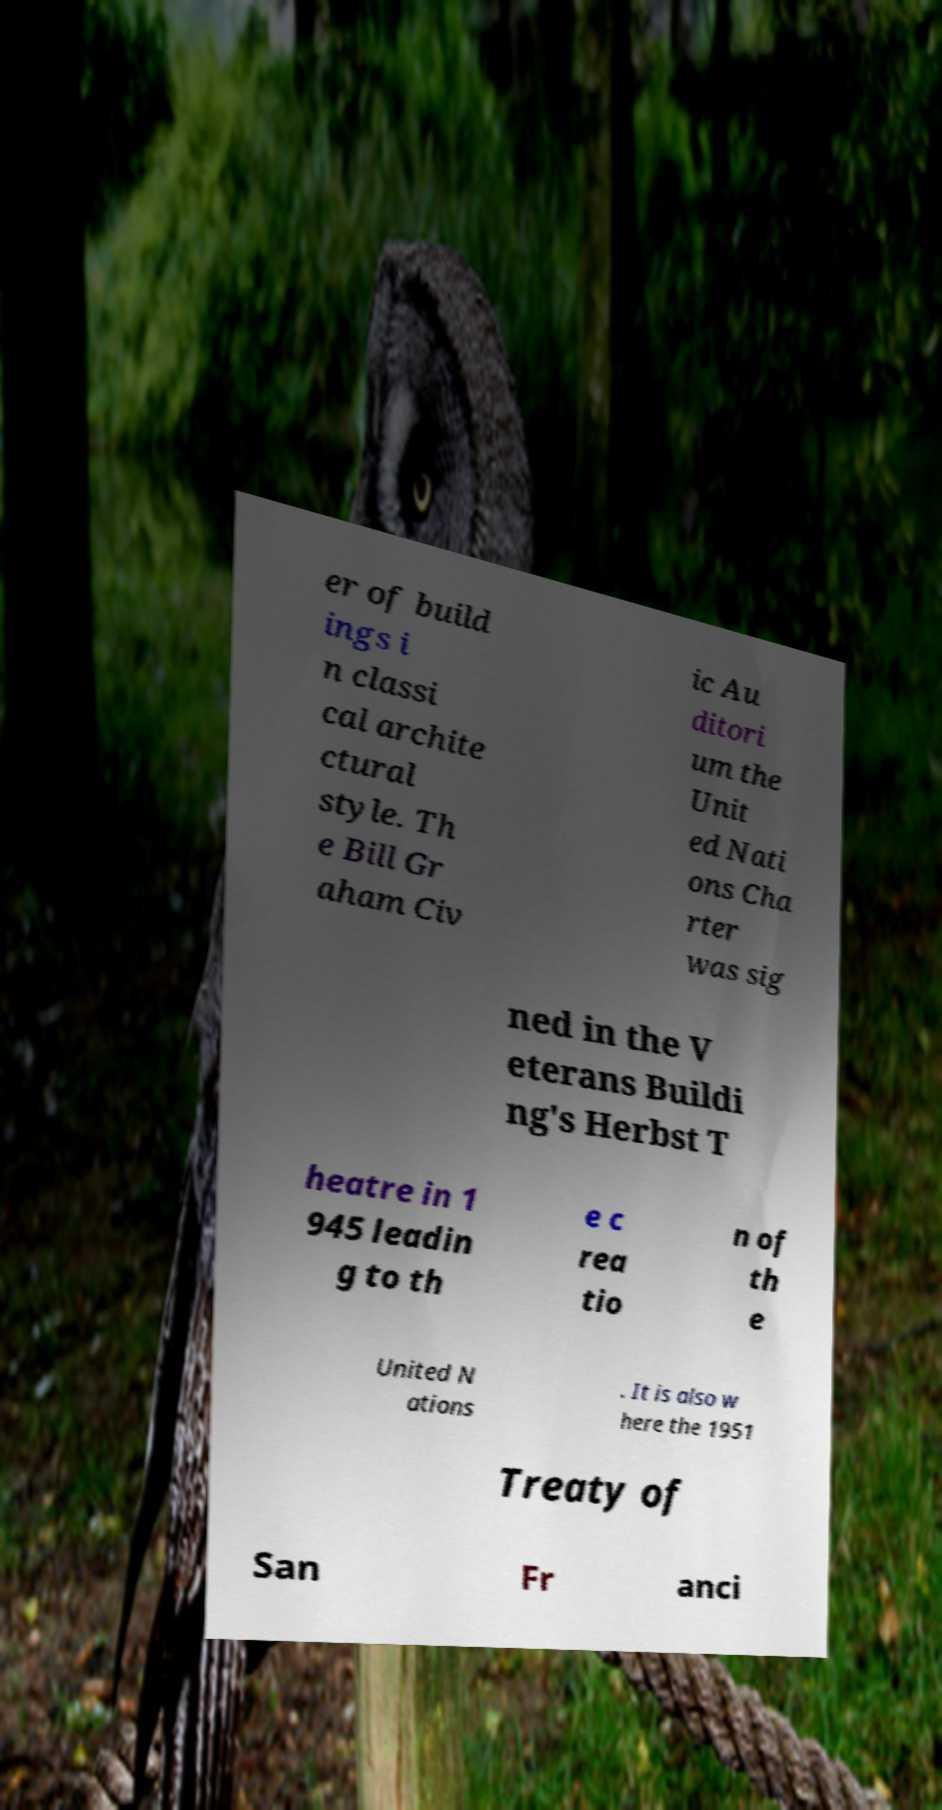Could you extract and type out the text from this image? er of build ings i n classi cal archite ctural style. Th e Bill Gr aham Civ ic Au ditori um the Unit ed Nati ons Cha rter was sig ned in the V eterans Buildi ng's Herbst T heatre in 1 945 leadin g to th e c rea tio n of th e United N ations . It is also w here the 1951 Treaty of San Fr anci 